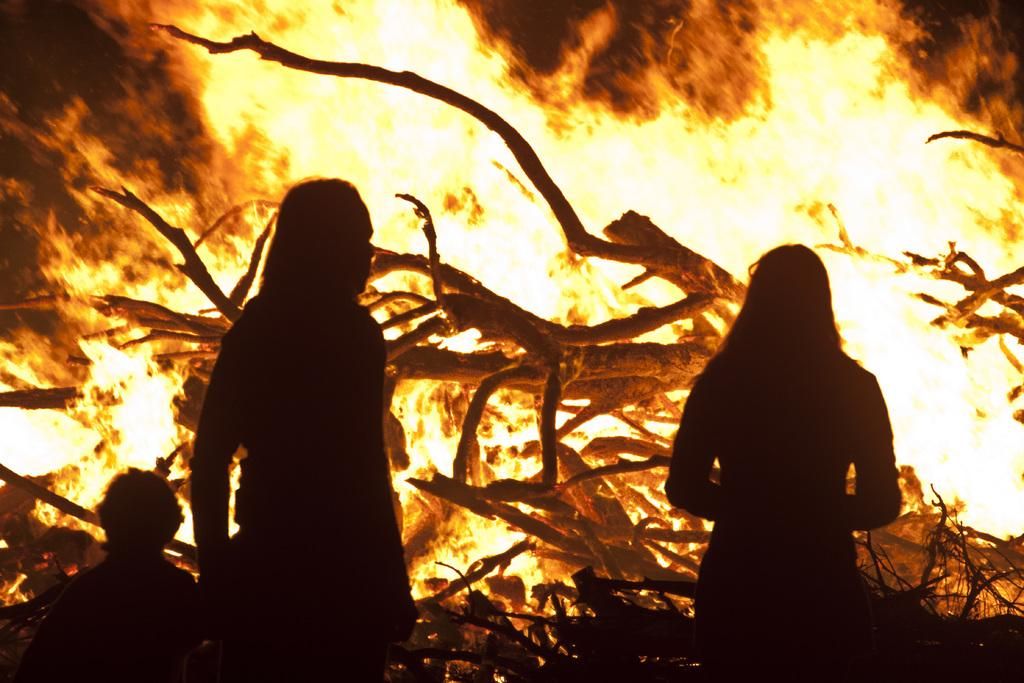What is the primary element in the image? There is fire in the image. What type of natural environment can be seen in the image? There are trees visible in the image. How many people are present in the image? There are three people standing and looking at the fire. What angle is the match being held at in the image? There is no match present in the image. 